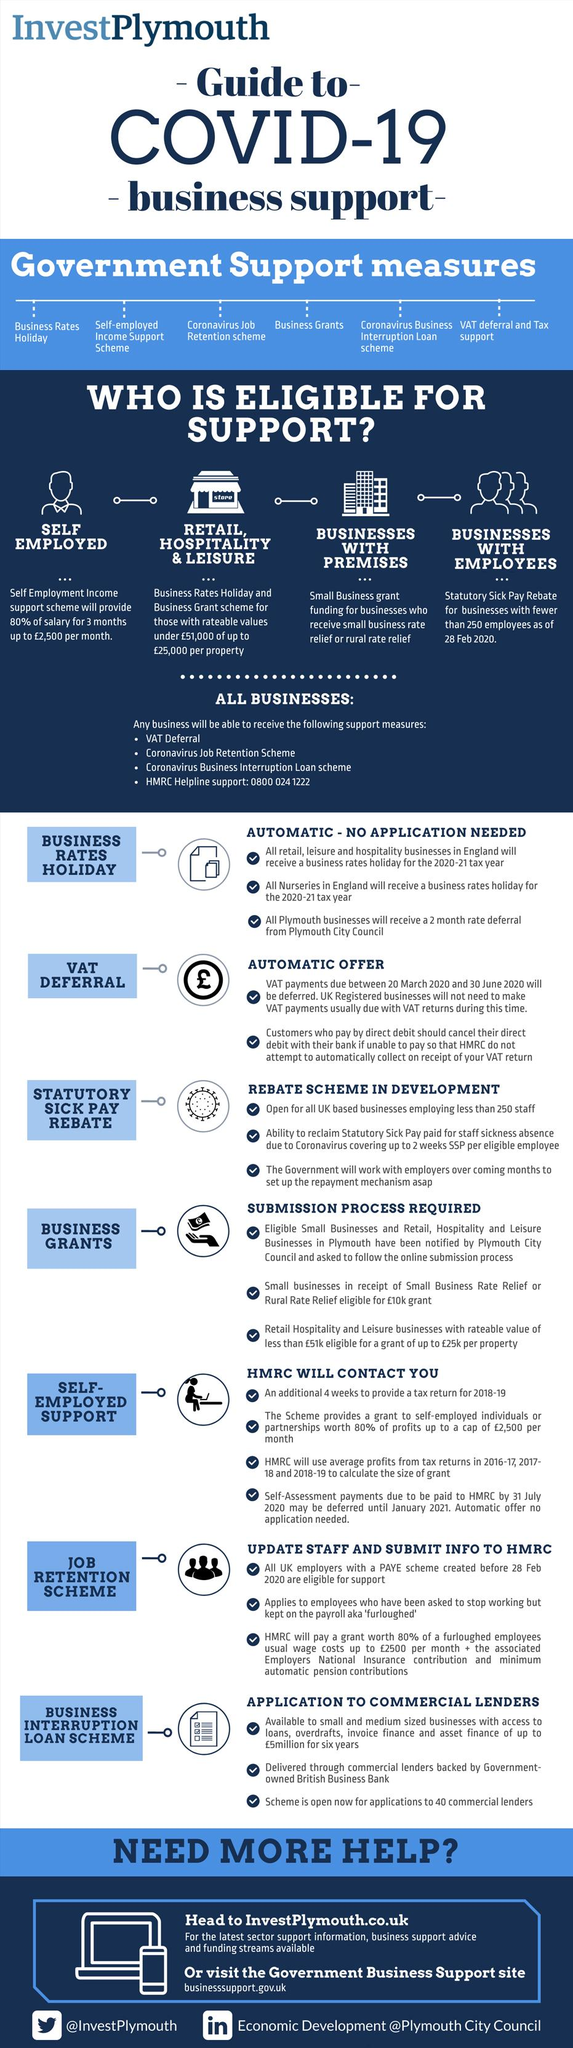Mention a couple of crucial points in this snapshot. The fourth item given under support measures is business grants. HMRC will calculate the size of the grant for self-employed individuals based on their average profits from tax returns in 2016-2017, 2017-2018, and 2018-2019. There are support schemes that businesses can access without needing to apply, such as business rates holidays and VAT deferrals. The application procedure for the different support schemes provided is outlined in detail in the document. There are four tips provided under the subtopic of self-employed support for the application procedure. 